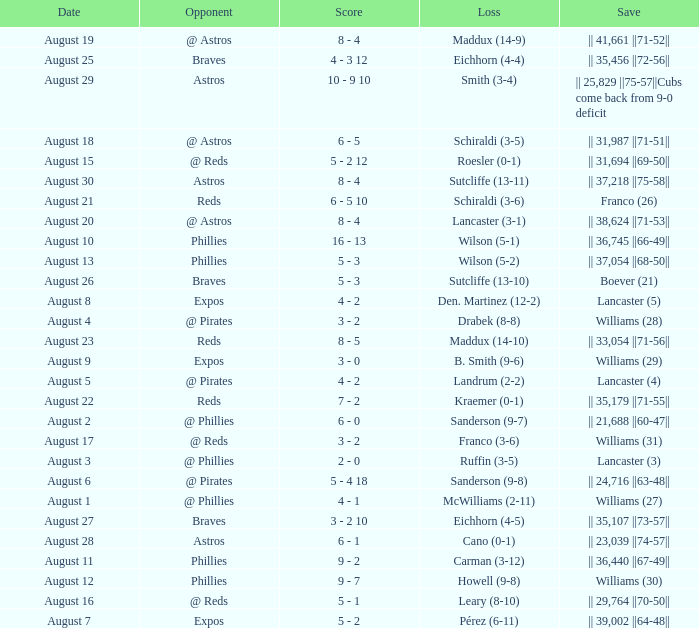Name the score for save of lancaster (3) 2 - 0. 